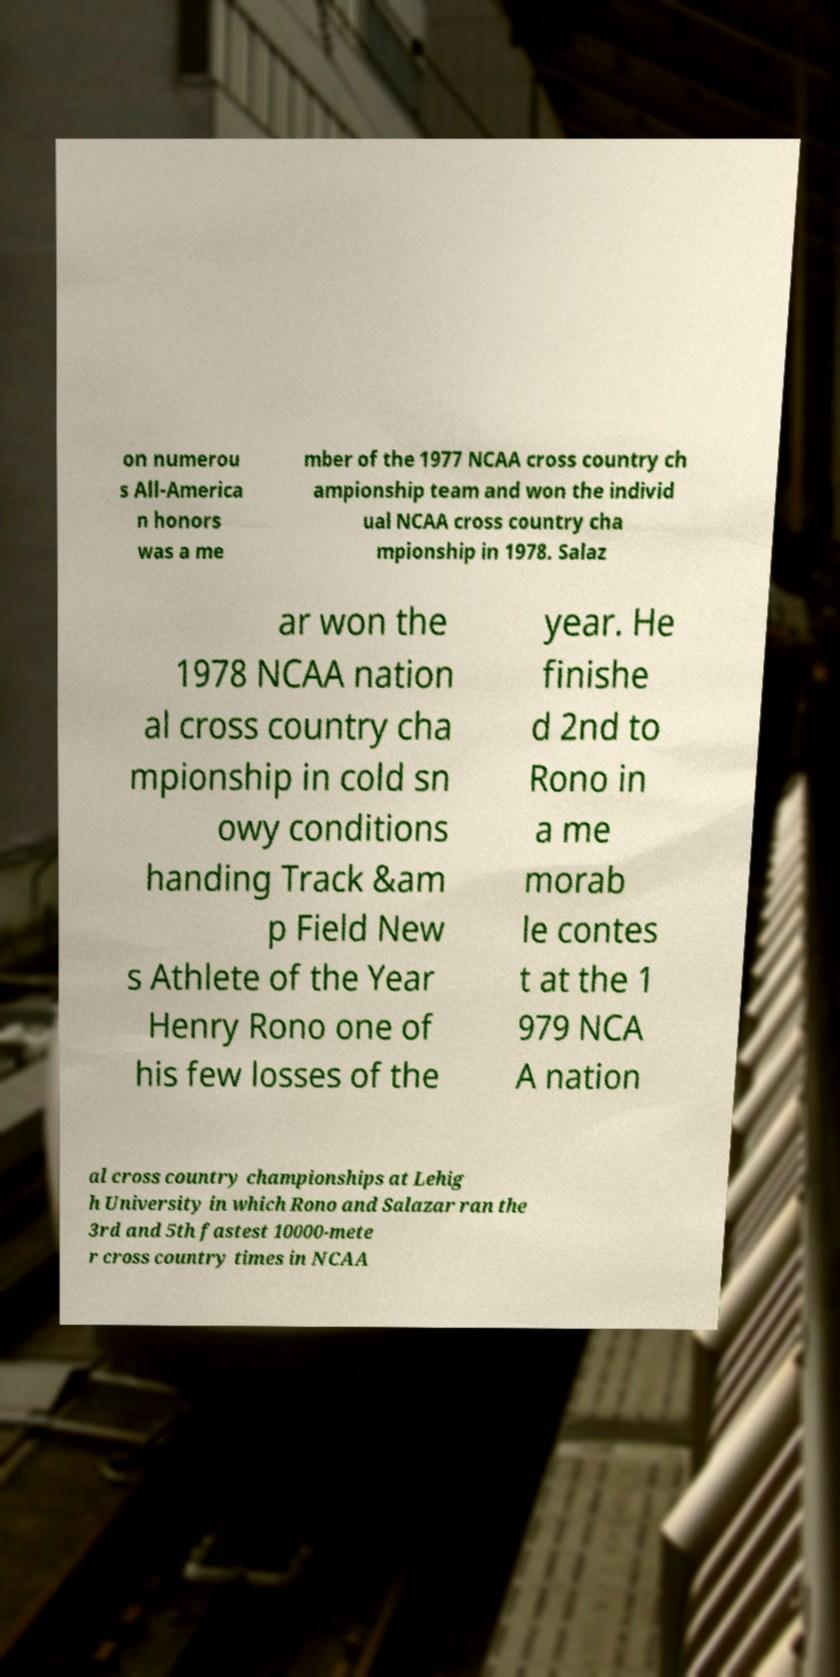Can you accurately transcribe the text from the provided image for me? on numerou s All-America n honors was a me mber of the 1977 NCAA cross country ch ampionship team and won the individ ual NCAA cross country cha mpionship in 1978. Salaz ar won the 1978 NCAA nation al cross country cha mpionship in cold sn owy conditions handing Track &am p Field New s Athlete of the Year Henry Rono one of his few losses of the year. He finishe d 2nd to Rono in a me morab le contes t at the 1 979 NCA A nation al cross country championships at Lehig h University in which Rono and Salazar ran the 3rd and 5th fastest 10000-mete r cross country times in NCAA 